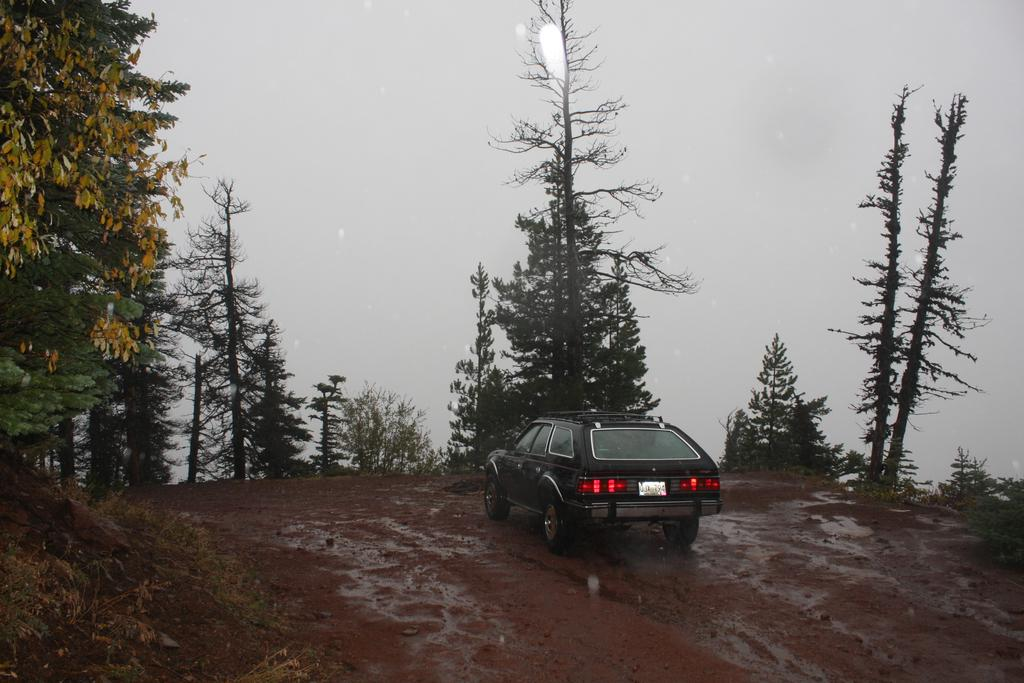What is the main subject of the image? The main subject of the image is a car. Where is the car located in the image? The car is on a road in the image. What can be seen on the sides of the road? There are trees on the sides of the road in the image. What is visible in the background of the image? The sky is visible in the background of the image. What type of behavior does the finger exhibit in the image? There is no finger present in the image, so it is not possible to determine any behavior. 